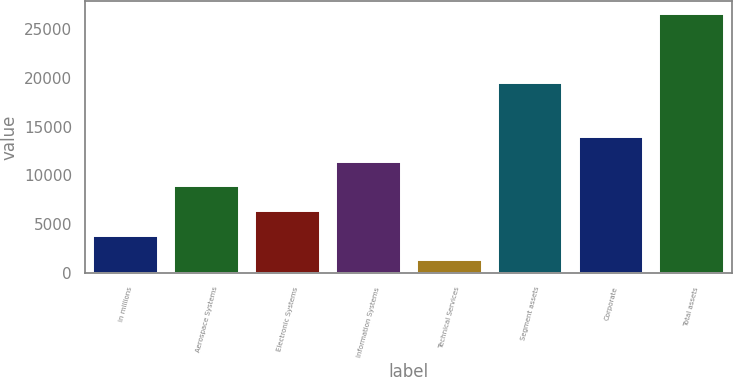Convert chart to OTSL. <chart><loc_0><loc_0><loc_500><loc_500><bar_chart><fcel>in millions<fcel>Aerospace Systems<fcel>Electronic Systems<fcel>Information Systems<fcel>Technical Services<fcel>Segment assets<fcel>Corporate<fcel>Total assets<nl><fcel>3836<fcel>8882<fcel>6359<fcel>11405<fcel>1313<fcel>19461<fcel>13928<fcel>26543<nl></chart> 